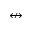Convert formula to latex. <formula><loc_0><loc_0><loc_500><loc_500>\ n l e f t r i g h t a r r o w</formula> 